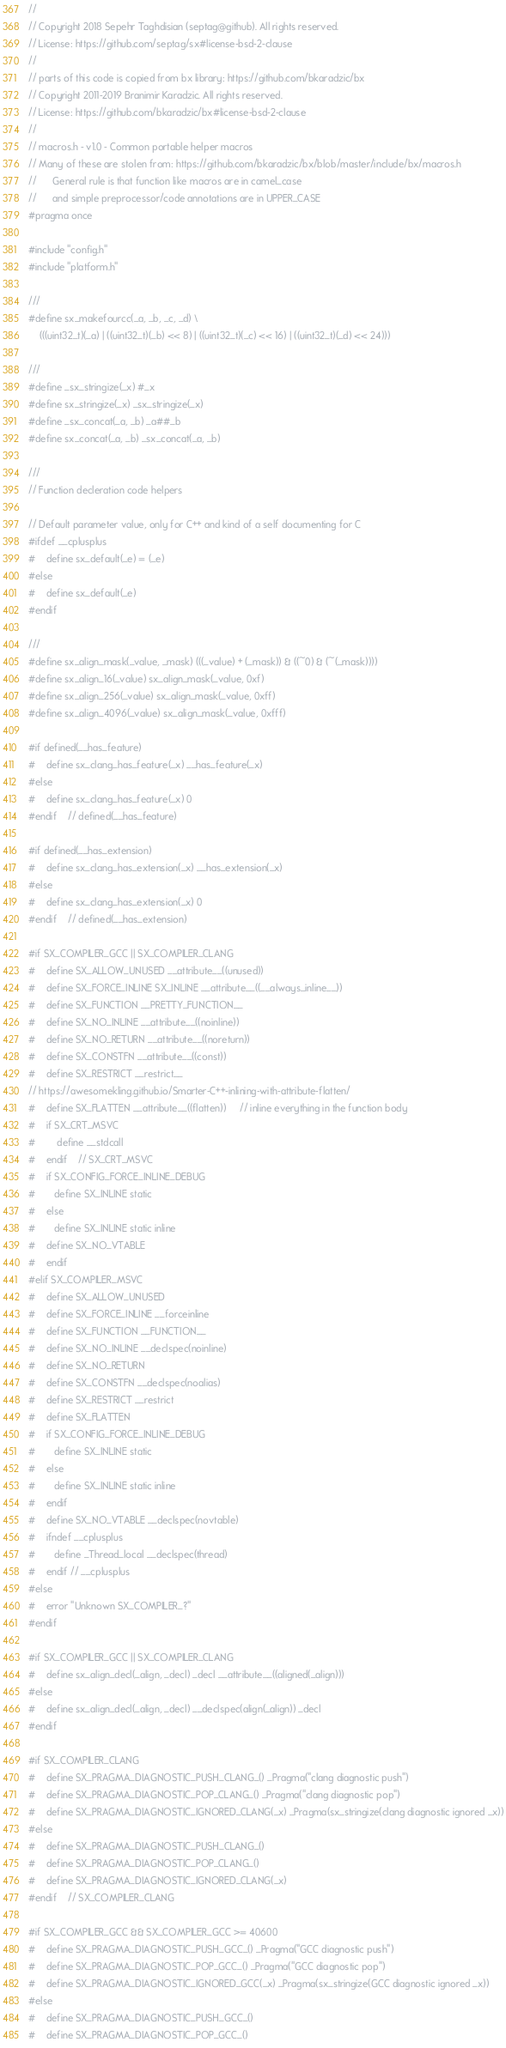<code> <loc_0><loc_0><loc_500><loc_500><_C_>//
// Copyright 2018 Sepehr Taghdisian (septag@github). All rights reserved.
// License: https://github.com/septag/sx#license-bsd-2-clause
//
// parts of this code is copied from bx library: https://github.com/bkaradzic/bx
// Copyright 2011-2019 Branimir Karadzic. All rights reserved.
// License: https://github.com/bkaradzic/bx#license-bsd-2-clause
//
// macros.h - v1.0 - Common portable helper macros
// Many of these are stolen from: https://github.com/bkaradzic/bx/blob/master/include/bx/macros.h
//      General rule is that function like macros are in camel_case
//      and simple preprocessor/code annotations are in UPPER_CASE
#pragma once

#include "config.h"
#include "platform.h"

///
#define sx_makefourcc(_a, _b, _c, _d) \
    (((uint32_t)(_a) | ((uint32_t)(_b) << 8) | ((uint32_t)(_c) << 16) | ((uint32_t)(_d) << 24)))

///
#define _sx_stringize(_x) #_x
#define sx_stringize(_x) _sx_stringize(_x)
#define _sx_concat(_a, _b) _a##_b
#define sx_concat(_a, _b) _sx_concat(_a, _b)

///
// Function decleration code helpers

// Default parameter value, only for C++ and kind of a self documenting for C
#ifdef __cplusplus
#    define sx_default(_e) = (_e)
#else
#    define sx_default(_e)
#endif

///
#define sx_align_mask(_value, _mask) (((_value) + (_mask)) & ((~0) & (~(_mask))))
#define sx_align_16(_value) sx_align_mask(_value, 0xf)
#define sx_align_256(_value) sx_align_mask(_value, 0xff)
#define sx_align_4096(_value) sx_align_mask(_value, 0xfff)

#if defined(__has_feature)
#    define sx_clang_has_feature(_x) __has_feature(_x)
#else
#    define sx_clang_has_feature(_x) 0
#endif    // defined(__has_feature)

#if defined(__has_extension)
#    define sx_clang_has_extension(_x) __has_extension(_x)
#else
#    define sx_clang_has_extension(_x) 0
#endif    // defined(__has_extension)

#if SX_COMPILER_GCC || SX_COMPILER_CLANG
#    define SX_ALLOW_UNUSED __attribute__((unused))
#    define SX_FORCE_INLINE SX_INLINE __attribute__((__always_inline__))
#    define SX_FUNCTION __PRETTY_FUNCTION__
#    define SX_NO_INLINE __attribute__((noinline))
#    define SX_NO_RETURN __attribute__((noreturn))
#    define SX_CONSTFN __attribute__((const))
#    define SX_RESTRICT __restrict__
// https://awesomekling.github.io/Smarter-C++-inlining-with-attribute-flatten/
#    define SX_FLATTEN __attribute__((flatten))     // inline everything in the function body
#    if SX_CRT_MSVC
#        define __stdcall
#    endif    // SX_CRT_MSVC
#    if SX_CONFIG_FORCE_INLINE_DEBUG
#       define SX_INLINE static 
#    else
#       define SX_INLINE static inline  
#    define SX_NO_VTABLE 
#    endif
#elif SX_COMPILER_MSVC
#    define SX_ALLOW_UNUSED
#    define SX_FORCE_INLINE __forceinline
#    define SX_FUNCTION __FUNCTION__
#    define SX_NO_INLINE __declspec(noinline)
#    define SX_NO_RETURN
#    define SX_CONSTFN __declspec(noalias)
#    define SX_RESTRICT __restrict
#    define SX_FLATTEN 
#    if SX_CONFIG_FORCE_INLINE_DEBUG
#       define SX_INLINE static 
#    else
#       define SX_INLINE static inline  
#    endif
#    define SX_NO_VTABLE __declspec(novtable)
#    ifndef __cplusplus
#       define _Thread_local __declspec(thread)
#    endif // __cplusplus
#else
#    error "Unknown SX_COMPILER_?"
#endif

#if SX_COMPILER_GCC || SX_COMPILER_CLANG
#    define sx_align_decl(_align, _decl) _decl __attribute__((aligned(_align)))
#else
#    define sx_align_decl(_align, _decl) __declspec(align(_align)) _decl
#endif

#if SX_COMPILER_CLANG
#    define SX_PRAGMA_DIAGNOSTIC_PUSH_CLANG_() _Pragma("clang diagnostic push")
#    define SX_PRAGMA_DIAGNOSTIC_POP_CLANG_() _Pragma("clang diagnostic pop")
#    define SX_PRAGMA_DIAGNOSTIC_IGNORED_CLANG(_x) _Pragma(sx_stringize(clang diagnostic ignored _x))
#else
#    define SX_PRAGMA_DIAGNOSTIC_PUSH_CLANG_()
#    define SX_PRAGMA_DIAGNOSTIC_POP_CLANG_()
#    define SX_PRAGMA_DIAGNOSTIC_IGNORED_CLANG(_x)
#endif    // SX_COMPILER_CLANG

#if SX_COMPILER_GCC && SX_COMPILER_GCC >= 40600
#    define SX_PRAGMA_DIAGNOSTIC_PUSH_GCC_() _Pragma("GCC diagnostic push")
#    define SX_PRAGMA_DIAGNOSTIC_POP_GCC_() _Pragma("GCC diagnostic pop")
#    define SX_PRAGMA_DIAGNOSTIC_IGNORED_GCC(_x) _Pragma(sx_stringize(GCC diagnostic ignored _x))
#else
#    define SX_PRAGMA_DIAGNOSTIC_PUSH_GCC_()
#    define SX_PRAGMA_DIAGNOSTIC_POP_GCC_()</code> 